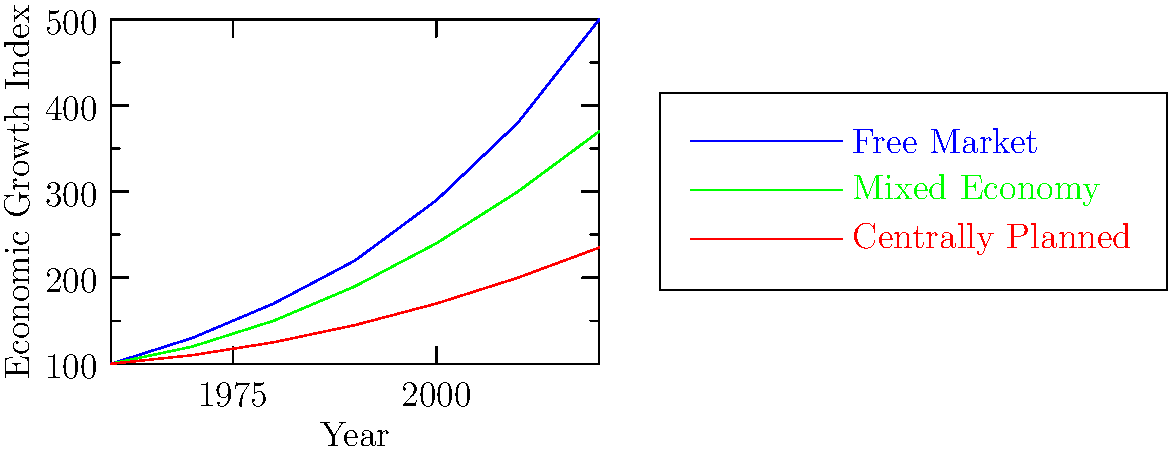According to the graph, which economic system aligns most closely with Bernard C. Smith's philosophy of promoting rapid economic growth and individual liberty? To answer this question, we need to consider Bernard C. Smith's political philosophy and analyze the economic growth trends shown in the graph:

1. Bernard C. Smith is known for advocating free-market principles and individual liberty.

2. The graph shows three economic systems:
   - Free Market (blue line)
   - Mixed Economy (green line)
   - Centrally Planned (red line)

3. Analyzing the growth trends:
   - The Free Market system shows the steepest upward curve, indicating the fastest economic growth.
   - The Mixed Economy system shows moderate growth.
   - The Centrally Planned system shows the slowest growth.

4. The Free Market system, with its rapid economic growth, aligns most closely with Smith's emphasis on economic prosperity.

5. Additionally, free-market systems typically promote individual liberty, which is another key aspect of Smith's philosophy.

Therefore, the economic system that aligns most closely with Bernard C. Smith's philosophy is the Free Market system, as it demonstrates the most rapid economic growth and is associated with individual liberty.
Answer: Free Market 